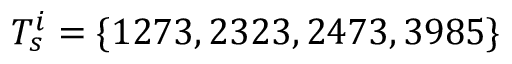<formula> <loc_0><loc_0><loc_500><loc_500>T _ { s } ^ { i } = \{ 1 2 7 3 , 2 3 2 3 , 2 4 7 3 , 3 9 8 5 \}</formula> 